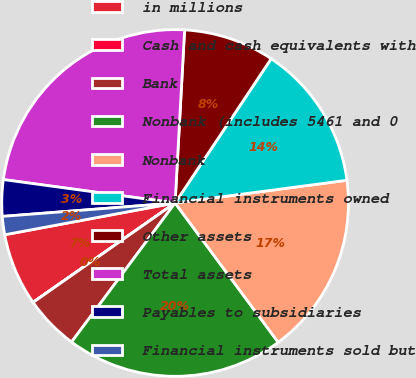Convert chart to OTSL. <chart><loc_0><loc_0><loc_500><loc_500><pie_chart><fcel>in millions<fcel>Cash and cash equivalents with<fcel>Bank<fcel>Nonbank (includes 5461 and 0<fcel>Nonbank<fcel>Financial instruments owned<fcel>Other assets<fcel>Total assets<fcel>Payables to subsidiaries<fcel>Financial instruments sold but<nl><fcel>6.78%<fcel>0.01%<fcel>5.09%<fcel>20.33%<fcel>16.95%<fcel>13.56%<fcel>8.48%<fcel>23.72%<fcel>3.39%<fcel>1.7%<nl></chart> 